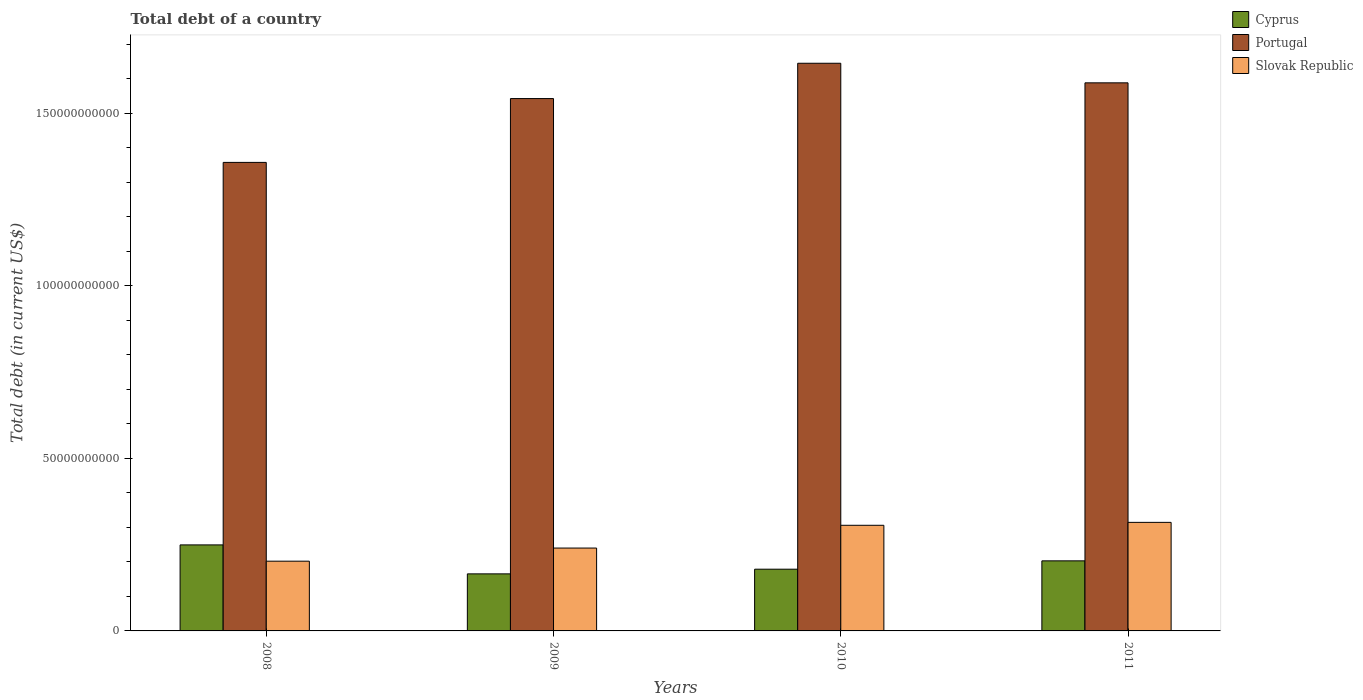Are the number of bars per tick equal to the number of legend labels?
Ensure brevity in your answer.  Yes. Are the number of bars on each tick of the X-axis equal?
Keep it short and to the point. Yes. In how many cases, is the number of bars for a given year not equal to the number of legend labels?
Give a very brief answer. 0. What is the debt in Cyprus in 2008?
Make the answer very short. 2.49e+1. Across all years, what is the maximum debt in Portugal?
Keep it short and to the point. 1.64e+11. Across all years, what is the minimum debt in Cyprus?
Provide a succinct answer. 1.65e+1. In which year was the debt in Slovak Republic minimum?
Provide a succinct answer. 2008. What is the total debt in Slovak Republic in the graph?
Offer a terse response. 1.06e+11. What is the difference between the debt in Slovak Republic in 2008 and that in 2010?
Provide a succinct answer. -1.04e+1. What is the difference between the debt in Portugal in 2011 and the debt in Slovak Republic in 2009?
Your answer should be very brief. 1.35e+11. What is the average debt in Cyprus per year?
Your answer should be very brief. 1.99e+1. In the year 2010, what is the difference between the debt in Portugal and debt in Cyprus?
Your answer should be compact. 1.47e+11. What is the ratio of the debt in Portugal in 2008 to that in 2010?
Your response must be concise. 0.83. Is the difference between the debt in Portugal in 2008 and 2011 greater than the difference between the debt in Cyprus in 2008 and 2011?
Keep it short and to the point. No. What is the difference between the highest and the second highest debt in Portugal?
Offer a very short reply. 5.67e+09. What is the difference between the highest and the lowest debt in Cyprus?
Make the answer very short. 8.39e+09. In how many years, is the debt in Portugal greater than the average debt in Portugal taken over all years?
Ensure brevity in your answer.  3. Is the sum of the debt in Slovak Republic in 2008 and 2009 greater than the maximum debt in Portugal across all years?
Your answer should be compact. No. What does the 2nd bar from the left in 2008 represents?
Provide a succinct answer. Portugal. What does the 1st bar from the right in 2009 represents?
Your response must be concise. Slovak Republic. Is it the case that in every year, the sum of the debt in Slovak Republic and debt in Portugal is greater than the debt in Cyprus?
Keep it short and to the point. Yes. Are all the bars in the graph horizontal?
Ensure brevity in your answer.  No. What is the difference between two consecutive major ticks on the Y-axis?
Your answer should be compact. 5.00e+1. How many legend labels are there?
Give a very brief answer. 3. How are the legend labels stacked?
Your response must be concise. Vertical. What is the title of the graph?
Provide a succinct answer. Total debt of a country. What is the label or title of the X-axis?
Ensure brevity in your answer.  Years. What is the label or title of the Y-axis?
Offer a very short reply. Total debt (in current US$). What is the Total debt (in current US$) in Cyprus in 2008?
Your response must be concise. 2.49e+1. What is the Total debt (in current US$) in Portugal in 2008?
Give a very brief answer. 1.36e+11. What is the Total debt (in current US$) in Slovak Republic in 2008?
Provide a succinct answer. 2.02e+1. What is the Total debt (in current US$) in Cyprus in 2009?
Make the answer very short. 1.65e+1. What is the Total debt (in current US$) of Portugal in 2009?
Ensure brevity in your answer.  1.54e+11. What is the Total debt (in current US$) of Slovak Republic in 2009?
Make the answer very short. 2.40e+1. What is the Total debt (in current US$) of Cyprus in 2010?
Your answer should be compact. 1.79e+1. What is the Total debt (in current US$) in Portugal in 2010?
Make the answer very short. 1.64e+11. What is the Total debt (in current US$) in Slovak Republic in 2010?
Offer a very short reply. 3.06e+1. What is the Total debt (in current US$) in Cyprus in 2011?
Offer a very short reply. 2.03e+1. What is the Total debt (in current US$) in Portugal in 2011?
Your answer should be compact. 1.59e+11. What is the Total debt (in current US$) in Slovak Republic in 2011?
Give a very brief answer. 3.15e+1. Across all years, what is the maximum Total debt (in current US$) of Cyprus?
Your answer should be very brief. 2.49e+1. Across all years, what is the maximum Total debt (in current US$) in Portugal?
Ensure brevity in your answer.  1.64e+11. Across all years, what is the maximum Total debt (in current US$) in Slovak Republic?
Offer a terse response. 3.15e+1. Across all years, what is the minimum Total debt (in current US$) in Cyprus?
Give a very brief answer. 1.65e+1. Across all years, what is the minimum Total debt (in current US$) in Portugal?
Provide a succinct answer. 1.36e+11. Across all years, what is the minimum Total debt (in current US$) in Slovak Republic?
Offer a very short reply. 2.02e+1. What is the total Total debt (in current US$) in Cyprus in the graph?
Make the answer very short. 7.97e+1. What is the total Total debt (in current US$) of Portugal in the graph?
Provide a succinct answer. 6.13e+11. What is the total Total debt (in current US$) in Slovak Republic in the graph?
Make the answer very short. 1.06e+11. What is the difference between the Total debt (in current US$) in Cyprus in 2008 and that in 2009?
Your response must be concise. 8.39e+09. What is the difference between the Total debt (in current US$) in Portugal in 2008 and that in 2009?
Offer a terse response. -1.85e+1. What is the difference between the Total debt (in current US$) of Slovak Republic in 2008 and that in 2009?
Your answer should be very brief. -3.80e+09. What is the difference between the Total debt (in current US$) in Cyprus in 2008 and that in 2010?
Offer a very short reply. 7.04e+09. What is the difference between the Total debt (in current US$) of Portugal in 2008 and that in 2010?
Provide a succinct answer. -2.87e+1. What is the difference between the Total debt (in current US$) in Slovak Republic in 2008 and that in 2010?
Ensure brevity in your answer.  -1.04e+1. What is the difference between the Total debt (in current US$) of Cyprus in 2008 and that in 2011?
Your answer should be very brief. 4.62e+09. What is the difference between the Total debt (in current US$) in Portugal in 2008 and that in 2011?
Ensure brevity in your answer.  -2.31e+1. What is the difference between the Total debt (in current US$) in Slovak Republic in 2008 and that in 2011?
Provide a short and direct response. -1.12e+1. What is the difference between the Total debt (in current US$) in Cyprus in 2009 and that in 2010?
Give a very brief answer. -1.35e+09. What is the difference between the Total debt (in current US$) in Portugal in 2009 and that in 2010?
Your response must be concise. -1.02e+1. What is the difference between the Total debt (in current US$) in Slovak Republic in 2009 and that in 2010?
Provide a short and direct response. -6.59e+09. What is the difference between the Total debt (in current US$) in Cyprus in 2009 and that in 2011?
Your response must be concise. -3.77e+09. What is the difference between the Total debt (in current US$) in Portugal in 2009 and that in 2011?
Keep it short and to the point. -4.56e+09. What is the difference between the Total debt (in current US$) of Slovak Republic in 2009 and that in 2011?
Your answer should be compact. -7.44e+09. What is the difference between the Total debt (in current US$) in Cyprus in 2010 and that in 2011?
Provide a short and direct response. -2.42e+09. What is the difference between the Total debt (in current US$) in Portugal in 2010 and that in 2011?
Provide a short and direct response. 5.67e+09. What is the difference between the Total debt (in current US$) of Slovak Republic in 2010 and that in 2011?
Offer a very short reply. -8.50e+08. What is the difference between the Total debt (in current US$) of Cyprus in 2008 and the Total debt (in current US$) of Portugal in 2009?
Your answer should be compact. -1.29e+11. What is the difference between the Total debt (in current US$) in Cyprus in 2008 and the Total debt (in current US$) in Slovak Republic in 2009?
Provide a succinct answer. 9.12e+08. What is the difference between the Total debt (in current US$) of Portugal in 2008 and the Total debt (in current US$) of Slovak Republic in 2009?
Ensure brevity in your answer.  1.12e+11. What is the difference between the Total debt (in current US$) of Cyprus in 2008 and the Total debt (in current US$) of Portugal in 2010?
Ensure brevity in your answer.  -1.40e+11. What is the difference between the Total debt (in current US$) in Cyprus in 2008 and the Total debt (in current US$) in Slovak Republic in 2010?
Make the answer very short. -5.68e+09. What is the difference between the Total debt (in current US$) in Portugal in 2008 and the Total debt (in current US$) in Slovak Republic in 2010?
Make the answer very short. 1.05e+11. What is the difference between the Total debt (in current US$) in Cyprus in 2008 and the Total debt (in current US$) in Portugal in 2011?
Provide a short and direct response. -1.34e+11. What is the difference between the Total debt (in current US$) of Cyprus in 2008 and the Total debt (in current US$) of Slovak Republic in 2011?
Offer a very short reply. -6.53e+09. What is the difference between the Total debt (in current US$) of Portugal in 2008 and the Total debt (in current US$) of Slovak Republic in 2011?
Your answer should be very brief. 1.04e+11. What is the difference between the Total debt (in current US$) in Cyprus in 2009 and the Total debt (in current US$) in Portugal in 2010?
Your response must be concise. -1.48e+11. What is the difference between the Total debt (in current US$) in Cyprus in 2009 and the Total debt (in current US$) in Slovak Republic in 2010?
Your answer should be very brief. -1.41e+1. What is the difference between the Total debt (in current US$) in Portugal in 2009 and the Total debt (in current US$) in Slovak Republic in 2010?
Your answer should be very brief. 1.24e+11. What is the difference between the Total debt (in current US$) of Cyprus in 2009 and the Total debt (in current US$) of Portugal in 2011?
Make the answer very short. -1.42e+11. What is the difference between the Total debt (in current US$) in Cyprus in 2009 and the Total debt (in current US$) in Slovak Republic in 2011?
Give a very brief answer. -1.49e+1. What is the difference between the Total debt (in current US$) in Portugal in 2009 and the Total debt (in current US$) in Slovak Republic in 2011?
Your answer should be compact. 1.23e+11. What is the difference between the Total debt (in current US$) in Cyprus in 2010 and the Total debt (in current US$) in Portugal in 2011?
Ensure brevity in your answer.  -1.41e+11. What is the difference between the Total debt (in current US$) in Cyprus in 2010 and the Total debt (in current US$) in Slovak Republic in 2011?
Give a very brief answer. -1.36e+1. What is the difference between the Total debt (in current US$) of Portugal in 2010 and the Total debt (in current US$) of Slovak Republic in 2011?
Make the answer very short. 1.33e+11. What is the average Total debt (in current US$) in Cyprus per year?
Ensure brevity in your answer.  1.99e+1. What is the average Total debt (in current US$) in Portugal per year?
Your response must be concise. 1.53e+11. What is the average Total debt (in current US$) in Slovak Republic per year?
Your response must be concise. 2.66e+1. In the year 2008, what is the difference between the Total debt (in current US$) of Cyprus and Total debt (in current US$) of Portugal?
Offer a very short reply. -1.11e+11. In the year 2008, what is the difference between the Total debt (in current US$) of Cyprus and Total debt (in current US$) of Slovak Republic?
Provide a succinct answer. 4.71e+09. In the year 2008, what is the difference between the Total debt (in current US$) of Portugal and Total debt (in current US$) of Slovak Republic?
Provide a short and direct response. 1.16e+11. In the year 2009, what is the difference between the Total debt (in current US$) in Cyprus and Total debt (in current US$) in Portugal?
Give a very brief answer. -1.38e+11. In the year 2009, what is the difference between the Total debt (in current US$) in Cyprus and Total debt (in current US$) in Slovak Republic?
Provide a short and direct response. -7.48e+09. In the year 2009, what is the difference between the Total debt (in current US$) in Portugal and Total debt (in current US$) in Slovak Republic?
Your answer should be compact. 1.30e+11. In the year 2010, what is the difference between the Total debt (in current US$) in Cyprus and Total debt (in current US$) in Portugal?
Offer a very short reply. -1.47e+11. In the year 2010, what is the difference between the Total debt (in current US$) of Cyprus and Total debt (in current US$) of Slovak Republic?
Provide a short and direct response. -1.27e+1. In the year 2010, what is the difference between the Total debt (in current US$) of Portugal and Total debt (in current US$) of Slovak Republic?
Make the answer very short. 1.34e+11. In the year 2011, what is the difference between the Total debt (in current US$) in Cyprus and Total debt (in current US$) in Portugal?
Provide a short and direct response. -1.39e+11. In the year 2011, what is the difference between the Total debt (in current US$) of Cyprus and Total debt (in current US$) of Slovak Republic?
Provide a short and direct response. -1.12e+1. In the year 2011, what is the difference between the Total debt (in current US$) in Portugal and Total debt (in current US$) in Slovak Republic?
Your answer should be compact. 1.27e+11. What is the ratio of the Total debt (in current US$) in Cyprus in 2008 to that in 2009?
Keep it short and to the point. 1.51. What is the ratio of the Total debt (in current US$) of Portugal in 2008 to that in 2009?
Your response must be concise. 0.88. What is the ratio of the Total debt (in current US$) in Slovak Republic in 2008 to that in 2009?
Provide a short and direct response. 0.84. What is the ratio of the Total debt (in current US$) in Cyprus in 2008 to that in 2010?
Your response must be concise. 1.39. What is the ratio of the Total debt (in current US$) in Portugal in 2008 to that in 2010?
Offer a terse response. 0.83. What is the ratio of the Total debt (in current US$) in Slovak Republic in 2008 to that in 2010?
Offer a terse response. 0.66. What is the ratio of the Total debt (in current US$) of Cyprus in 2008 to that in 2011?
Your answer should be very brief. 1.23. What is the ratio of the Total debt (in current US$) in Portugal in 2008 to that in 2011?
Offer a very short reply. 0.85. What is the ratio of the Total debt (in current US$) in Slovak Republic in 2008 to that in 2011?
Your response must be concise. 0.64. What is the ratio of the Total debt (in current US$) in Cyprus in 2009 to that in 2010?
Your answer should be very brief. 0.92. What is the ratio of the Total debt (in current US$) in Portugal in 2009 to that in 2010?
Your answer should be compact. 0.94. What is the ratio of the Total debt (in current US$) in Slovak Republic in 2009 to that in 2010?
Provide a short and direct response. 0.78. What is the ratio of the Total debt (in current US$) in Cyprus in 2009 to that in 2011?
Give a very brief answer. 0.81. What is the ratio of the Total debt (in current US$) in Portugal in 2009 to that in 2011?
Offer a terse response. 0.97. What is the ratio of the Total debt (in current US$) of Slovak Republic in 2009 to that in 2011?
Provide a short and direct response. 0.76. What is the ratio of the Total debt (in current US$) in Cyprus in 2010 to that in 2011?
Offer a very short reply. 0.88. What is the ratio of the Total debt (in current US$) of Portugal in 2010 to that in 2011?
Keep it short and to the point. 1.04. What is the ratio of the Total debt (in current US$) of Slovak Republic in 2010 to that in 2011?
Make the answer very short. 0.97. What is the difference between the highest and the second highest Total debt (in current US$) of Cyprus?
Your answer should be very brief. 4.62e+09. What is the difference between the highest and the second highest Total debt (in current US$) of Portugal?
Offer a terse response. 5.67e+09. What is the difference between the highest and the second highest Total debt (in current US$) in Slovak Republic?
Your answer should be compact. 8.50e+08. What is the difference between the highest and the lowest Total debt (in current US$) of Cyprus?
Provide a succinct answer. 8.39e+09. What is the difference between the highest and the lowest Total debt (in current US$) of Portugal?
Offer a very short reply. 2.87e+1. What is the difference between the highest and the lowest Total debt (in current US$) in Slovak Republic?
Your answer should be very brief. 1.12e+1. 